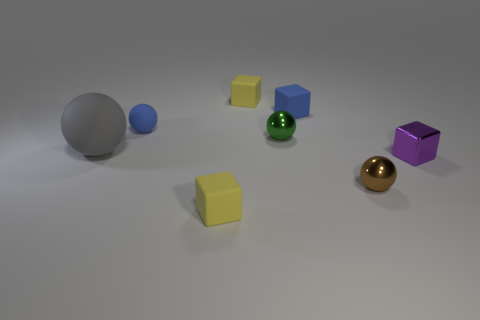Subtract all red cubes. Subtract all red balls. How many cubes are left? 4 Add 1 small rubber cylinders. How many objects exist? 9 Add 4 tiny purple things. How many tiny purple things exist? 5 Subtract 0 gray blocks. How many objects are left? 8 Subtract all small brown spheres. Subtract all tiny green balls. How many objects are left? 6 Add 4 small green objects. How many small green objects are left? 5 